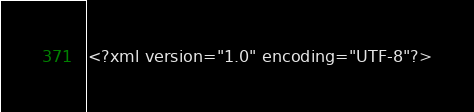Convert code to text. <code><loc_0><loc_0><loc_500><loc_500><_XML_><?xml version="1.0" encoding="UTF-8"?></code> 